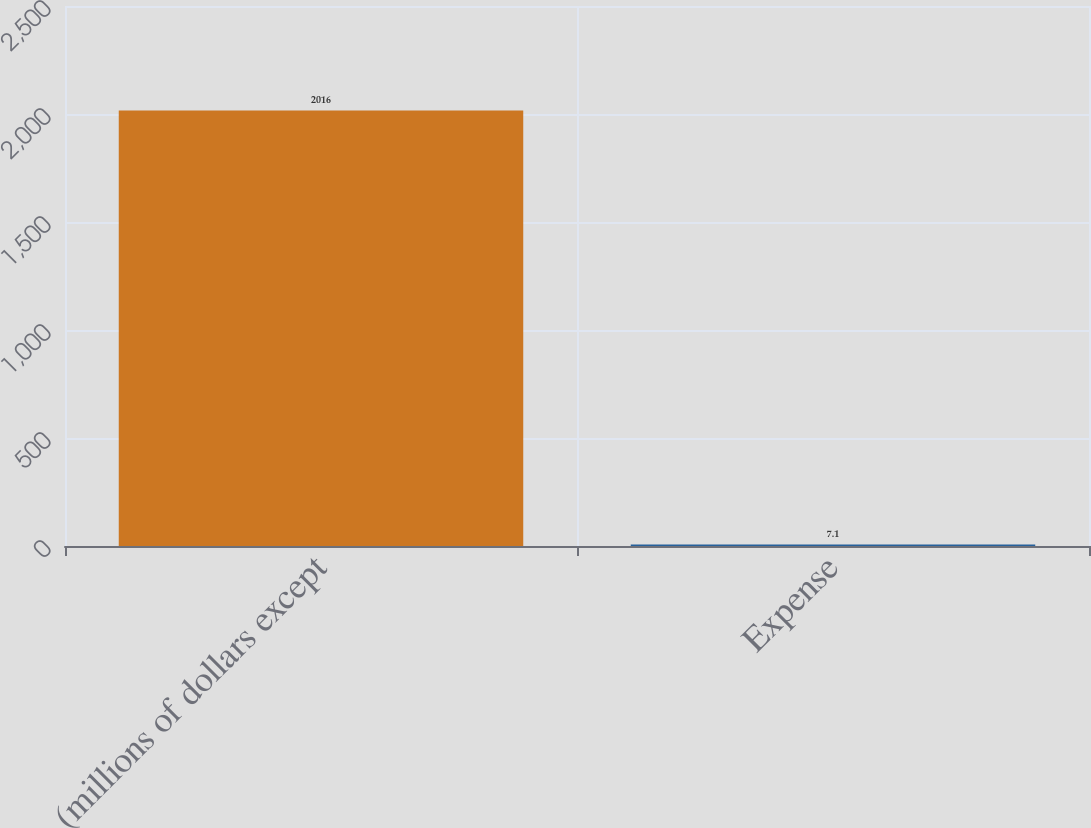Convert chart. <chart><loc_0><loc_0><loc_500><loc_500><bar_chart><fcel>(millions of dollars except<fcel>Expense<nl><fcel>2016<fcel>7.1<nl></chart> 